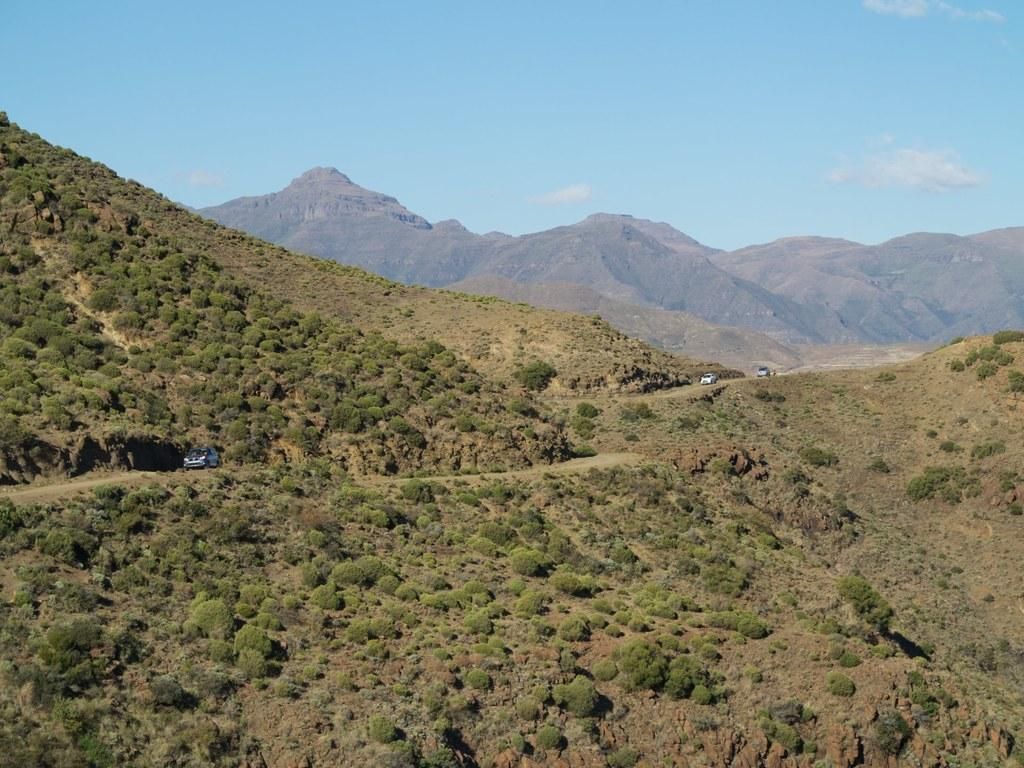What type of vegetation is present in the image? There are small trees in the image. What is located on the ground in the image? There is a car on the ground in the image. What type of geographical feature can be seen in the image? There are mountains visible in the image. What is visible above the ground in the image? The sky is visible in the image. Where are the children playing on the playground in the image? There is no playground present in the image. How many times does the person jump in the image? There is no person jumping in the image. What type of shoes are the characters wearing in the image? There are no characters or shoes present in the image. 